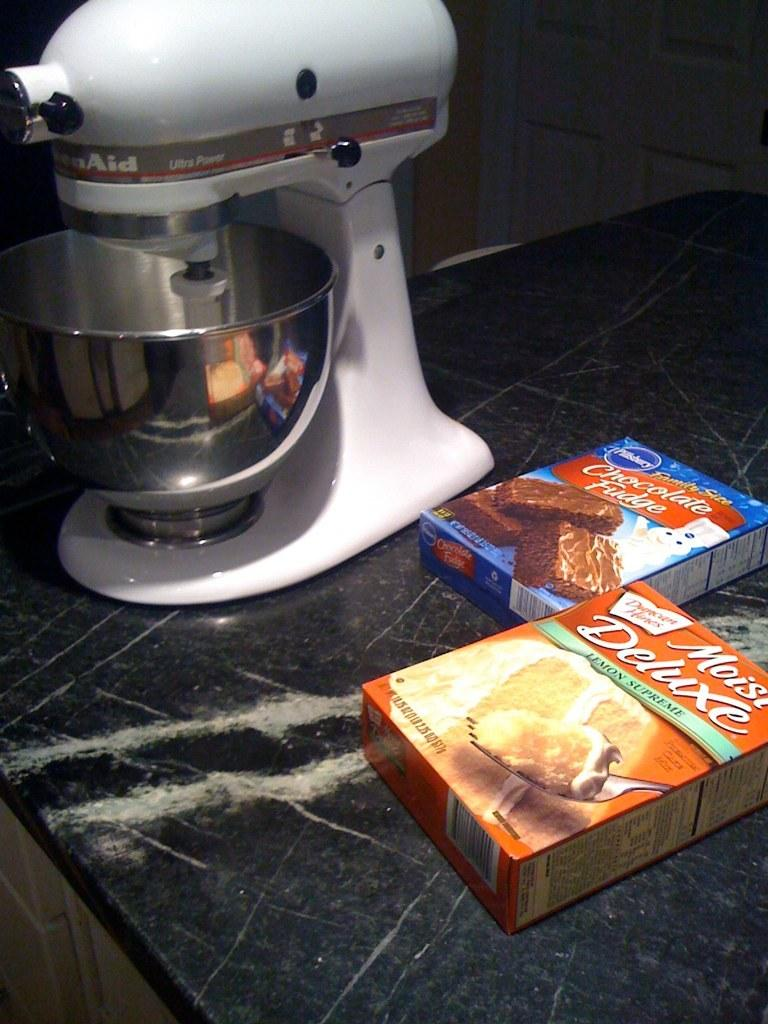<image>
Create a compact narrative representing the image presented. A box of moist Deluxe cake mix next to the blender. 